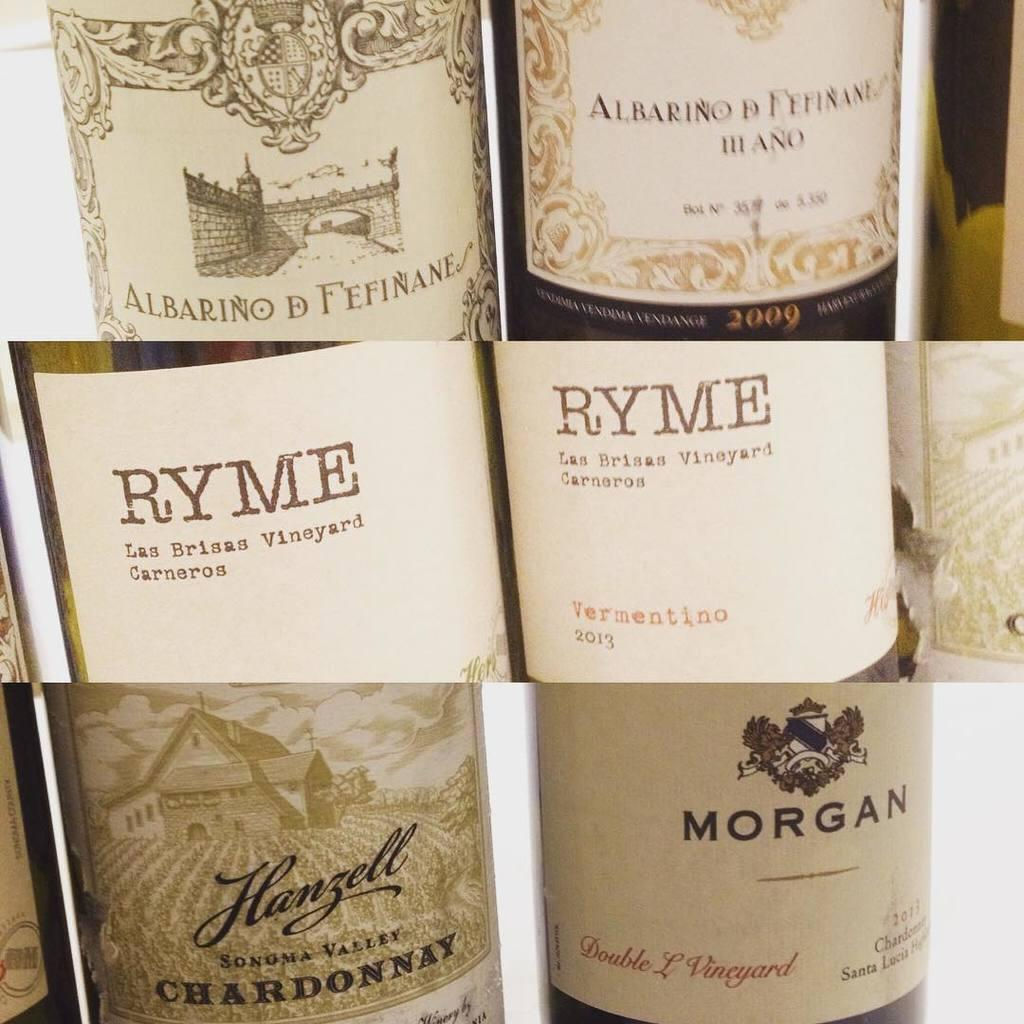<image>
Summarize the visual content of the image. A collage of different wine bottles, showing a close up of their labels, including Ryme Vermentino, and Hanzell Chardonnay are neatly placed together. 